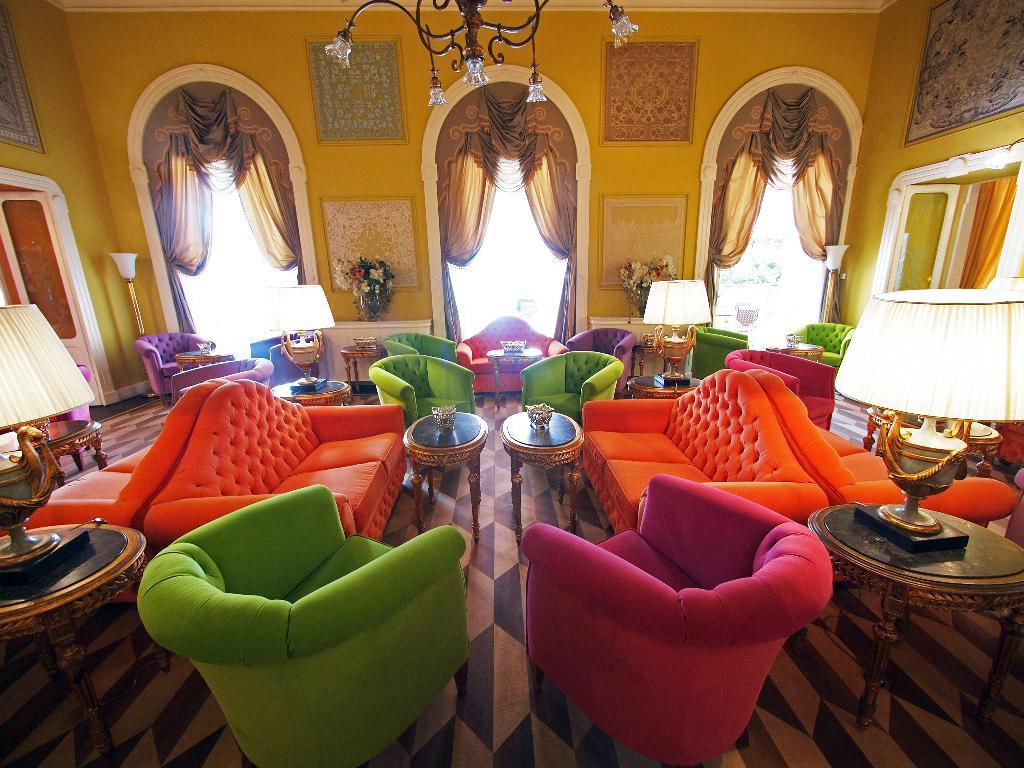What type of furniture is present in the image? There are sofas in the image. How many different colors can be seen on the sofas? The sofas come in different colors. What other types of furniture are visible in the image? There are tables in the image. What type of lighting is present in the image? Lamps are present in the image. What decorative elements can be seen in the image? Flowers are visible in the image. What type of window treatment is present in the image? Curtains are present in the image. What type of shirt is being worn by the sponge in the image? There is no sponge or shirt present in the image. What type of punishment is being administered in the image? There is no punishment or related activity depicted in the image. 